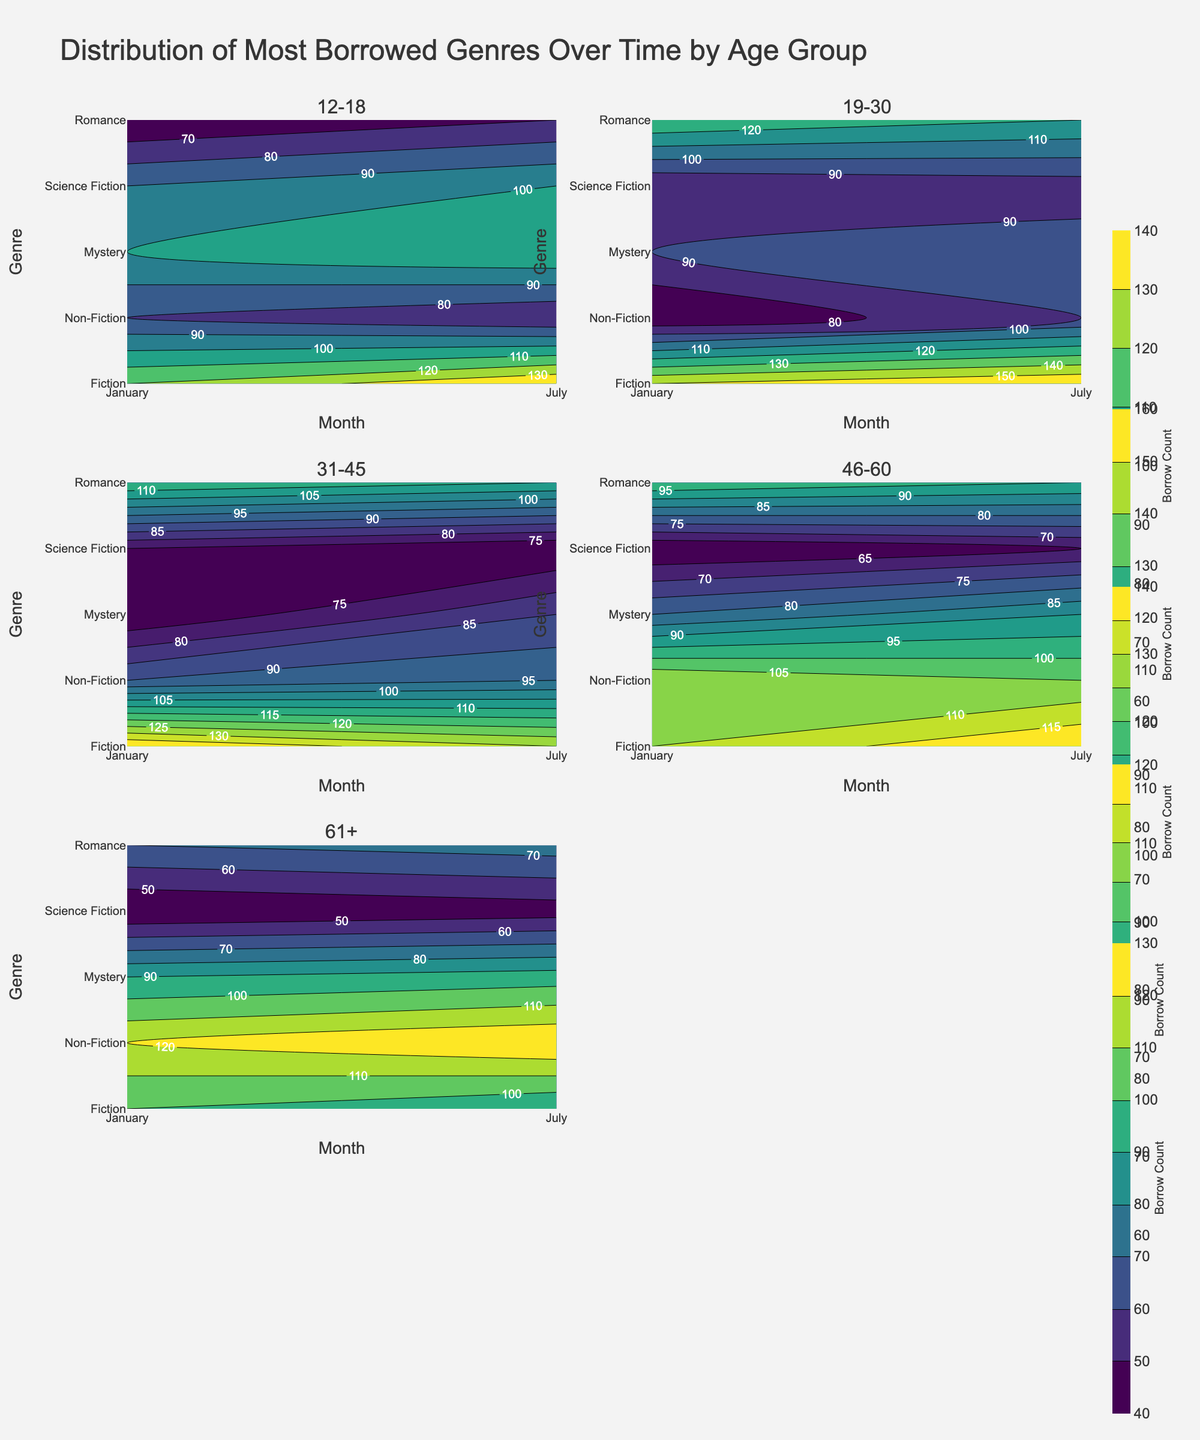How many age groups are analyzed in the figure? There are six subplot titles, each representing a different age group.
Answer: 6 Which genre shows the highest borrow count for the 19-30 age group in January? For the 19-30 age group in January, Romance shows the highest borrow count, which is represented by the darkest color in the January column.
Answer: Romance Does the Mystery genre's borrowing trend increase or decrease from January to July for the 31-45 age group? For the 31-45 age group, the borrowing count for Mystery increases from January (lighter color) to July (darker color).
Answer: Increase Which age group has the highest borrow count for Non-Fiction in July? By comparing the darkness of the contour colors in the July column for Non-Fiction across all age groups, the 61+ age group has the darkest color, indicating the highest borrow count.
Answer: 61+ In which month is Fiction most borrowed by the 46-60 age group? For the 46-60 age group, Fiction is most borrowed in July, marked by a darker contour color compared to January.
Answer: July Among the five mentioned genres, which one has the lowest borrow count for the 61+ age group in January? For the 61+ age group in January, Science Fiction has the lightest contour color, indicating the lowest borrow count.
Answer: Science Fiction What trend is observed in the borrowing pattern of Science Fiction for the 19-30 age group from January to July? For the 19-30 age group, the borrow count for Science Fiction slightly increases from January to July, as indicated by a darker shade in July.
Answer: Slight increase How does the borrow count of Romance compare between the 12-18 and 31-45 age groups in January? Romance borrow count is higher for the 31-45 age group in January (darker color) compared to the 12-18 age group.
Answer: Higher for 31-45 What's the overall trend in borrow count for Fiction across all age groups from January to July? To summarize the contour colors for Fiction across all age groups, some age groups show an increase, while others show a decrease in borrow count from January to July, indicating a mixed trend.
Answer: Mixed trend In July, which age group shows the highest diversity in borrowing different genres? By checking the range of contour colors (from light to dark) in the columns for July, the 19-30 age group shows diverse borrowing patterns across different genres, indicating the highest diversity.
Answer: 19-30 